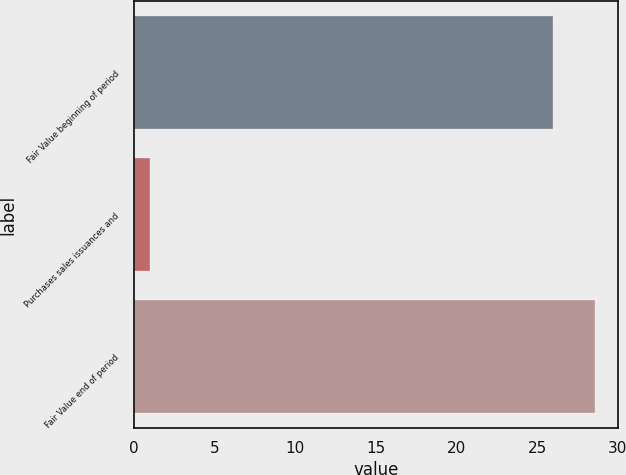<chart> <loc_0><loc_0><loc_500><loc_500><bar_chart><fcel>Fair Value beginning of period<fcel>Purchases sales issuances and<fcel>Fair Value end of period<nl><fcel>26<fcel>1<fcel>28.6<nl></chart> 